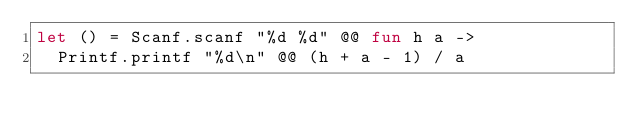Convert code to text. <code><loc_0><loc_0><loc_500><loc_500><_OCaml_>let () = Scanf.scanf "%d %d" @@ fun h a ->
  Printf.printf "%d\n" @@ (h + a - 1) / a
</code> 